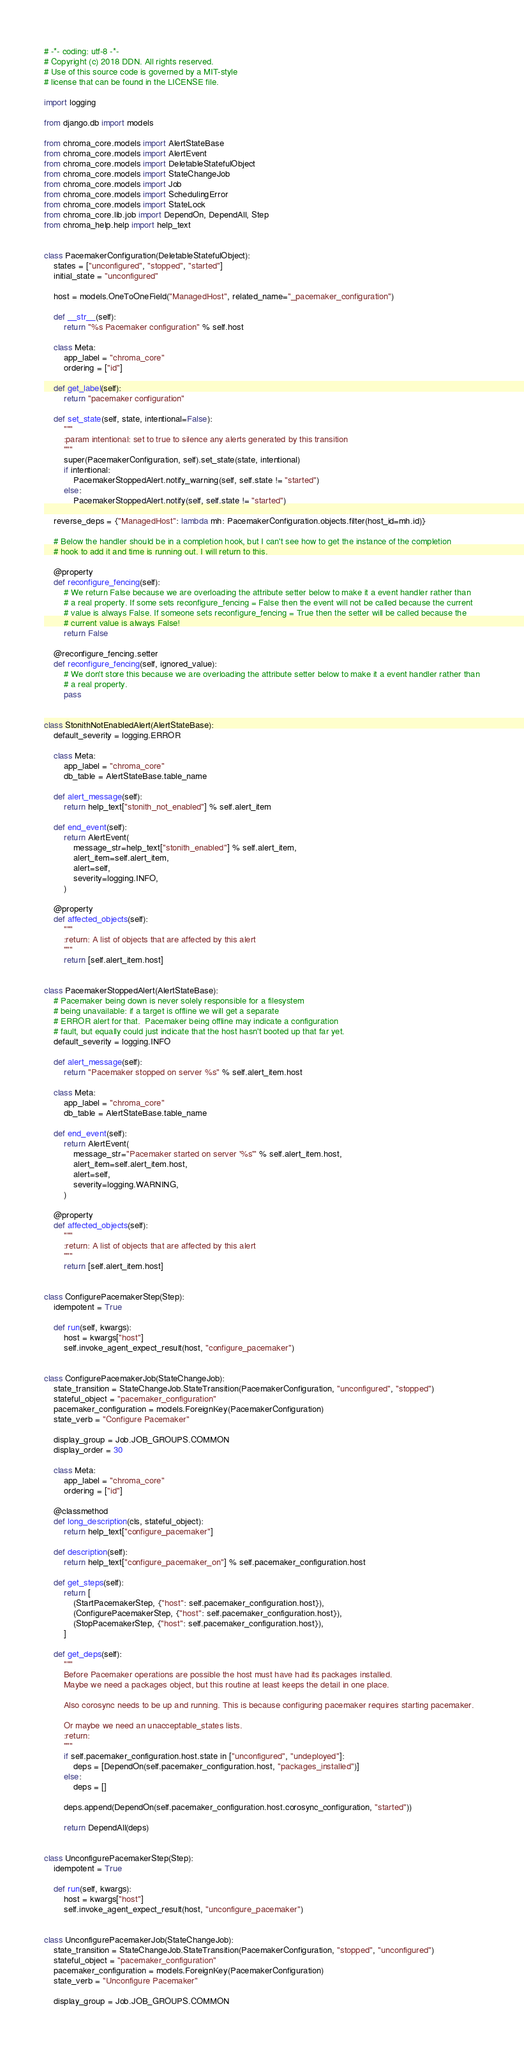Convert code to text. <code><loc_0><loc_0><loc_500><loc_500><_Python_># -*- coding: utf-8 -*-
# Copyright (c) 2018 DDN. All rights reserved.
# Use of this source code is governed by a MIT-style
# license that can be found in the LICENSE file.

import logging

from django.db import models

from chroma_core.models import AlertStateBase
from chroma_core.models import AlertEvent
from chroma_core.models import DeletableStatefulObject
from chroma_core.models import StateChangeJob
from chroma_core.models import Job
from chroma_core.models import SchedulingError
from chroma_core.models import StateLock
from chroma_core.lib.job import DependOn, DependAll, Step
from chroma_help.help import help_text


class PacemakerConfiguration(DeletableStatefulObject):
    states = ["unconfigured", "stopped", "started"]
    initial_state = "unconfigured"

    host = models.OneToOneField("ManagedHost", related_name="_pacemaker_configuration")

    def __str__(self):
        return "%s Pacemaker configuration" % self.host

    class Meta:
        app_label = "chroma_core"
        ordering = ["id"]

    def get_label(self):
        return "pacemaker configuration"

    def set_state(self, state, intentional=False):
        """
        :param intentional: set to true to silence any alerts generated by this transition
        """
        super(PacemakerConfiguration, self).set_state(state, intentional)
        if intentional:
            PacemakerStoppedAlert.notify_warning(self, self.state != "started")
        else:
            PacemakerStoppedAlert.notify(self, self.state != "started")

    reverse_deps = {"ManagedHost": lambda mh: PacemakerConfiguration.objects.filter(host_id=mh.id)}

    # Below the handler should be in a completion hook, but I can't see how to get the instance of the completion
    # hook to add it and time is running out. I will return to this.

    @property
    def reconfigure_fencing(self):
        # We return False because we are overloading the attribute setter below to make it a event handler rather than
        # a real property. If some sets reconfigure_fencing = False then the event will not be called because the current
        # value is always False. If someone sets reconfigure_fencing = True then the setter will be called because the
        # current value is always False!
        return False

    @reconfigure_fencing.setter
    def reconfigure_fencing(self, ignored_value):
        # We don't store this because we are overloading the attribute setter below to make it a event handler rather than
        # a real property.
        pass


class StonithNotEnabledAlert(AlertStateBase):
    default_severity = logging.ERROR

    class Meta:
        app_label = "chroma_core"
        db_table = AlertStateBase.table_name

    def alert_message(self):
        return help_text["stonith_not_enabled"] % self.alert_item

    def end_event(self):
        return AlertEvent(
            message_str=help_text["stonith_enabled"] % self.alert_item,
            alert_item=self.alert_item,
            alert=self,
            severity=logging.INFO,
        )

    @property
    def affected_objects(self):
        """
        :return: A list of objects that are affected by this alert
        """
        return [self.alert_item.host]


class PacemakerStoppedAlert(AlertStateBase):
    # Pacemaker being down is never solely responsible for a filesystem
    # being unavailable: if a target is offline we will get a separate
    # ERROR alert for that.  Pacemaker being offline may indicate a configuration
    # fault, but equally could just indicate that the host hasn't booted up that far yet.
    default_severity = logging.INFO

    def alert_message(self):
        return "Pacemaker stopped on server %s" % self.alert_item.host

    class Meta:
        app_label = "chroma_core"
        db_table = AlertStateBase.table_name

    def end_event(self):
        return AlertEvent(
            message_str="Pacemaker started on server '%s'" % self.alert_item.host,
            alert_item=self.alert_item.host,
            alert=self,
            severity=logging.WARNING,
        )

    @property
    def affected_objects(self):
        """
        :return: A list of objects that are affected by this alert
        """
        return [self.alert_item.host]


class ConfigurePacemakerStep(Step):
    idempotent = True

    def run(self, kwargs):
        host = kwargs["host"]
        self.invoke_agent_expect_result(host, "configure_pacemaker")


class ConfigurePacemakerJob(StateChangeJob):
    state_transition = StateChangeJob.StateTransition(PacemakerConfiguration, "unconfigured", "stopped")
    stateful_object = "pacemaker_configuration"
    pacemaker_configuration = models.ForeignKey(PacemakerConfiguration)
    state_verb = "Configure Pacemaker"

    display_group = Job.JOB_GROUPS.COMMON
    display_order = 30

    class Meta:
        app_label = "chroma_core"
        ordering = ["id"]

    @classmethod
    def long_description(cls, stateful_object):
        return help_text["configure_pacemaker"]

    def description(self):
        return help_text["configure_pacemaker_on"] % self.pacemaker_configuration.host

    def get_steps(self):
        return [
            (StartPacemakerStep, {"host": self.pacemaker_configuration.host}),
            (ConfigurePacemakerStep, {"host": self.pacemaker_configuration.host}),
            (StopPacemakerStep, {"host": self.pacemaker_configuration.host}),
        ]

    def get_deps(self):
        """
        Before Pacemaker operations are possible the host must have had its packages installed.
        Maybe we need a packages object, but this routine at least keeps the detail in one place.

        Also corosync needs to be up and running. This is because configuring pacemaker requires starting pacemaker.

        Or maybe we need an unacceptable_states lists.
        :return:
        """
        if self.pacemaker_configuration.host.state in ["unconfigured", "undeployed"]:
            deps = [DependOn(self.pacemaker_configuration.host, "packages_installed")]
        else:
            deps = []

        deps.append(DependOn(self.pacemaker_configuration.host.corosync_configuration, "started"))

        return DependAll(deps)


class UnconfigurePacemakerStep(Step):
    idempotent = True

    def run(self, kwargs):
        host = kwargs["host"]
        self.invoke_agent_expect_result(host, "unconfigure_pacemaker")


class UnconfigurePacemakerJob(StateChangeJob):
    state_transition = StateChangeJob.StateTransition(PacemakerConfiguration, "stopped", "unconfigured")
    stateful_object = "pacemaker_configuration"
    pacemaker_configuration = models.ForeignKey(PacemakerConfiguration)
    state_verb = "Unconfigure Pacemaker"

    display_group = Job.JOB_GROUPS.COMMON</code> 